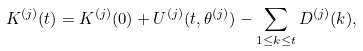Convert formula to latex. <formula><loc_0><loc_0><loc_500><loc_500>K ^ { ( j ) } ( t ) = K ^ { ( j ) } ( 0 ) + U ^ { ( j ) } ( t , \theta ^ { ( j ) } ) - \sum _ { 1 \leq k \leq t } D ^ { ( j ) } ( k ) ,</formula> 